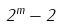<formula> <loc_0><loc_0><loc_500><loc_500>2 ^ { m } - 2</formula> 